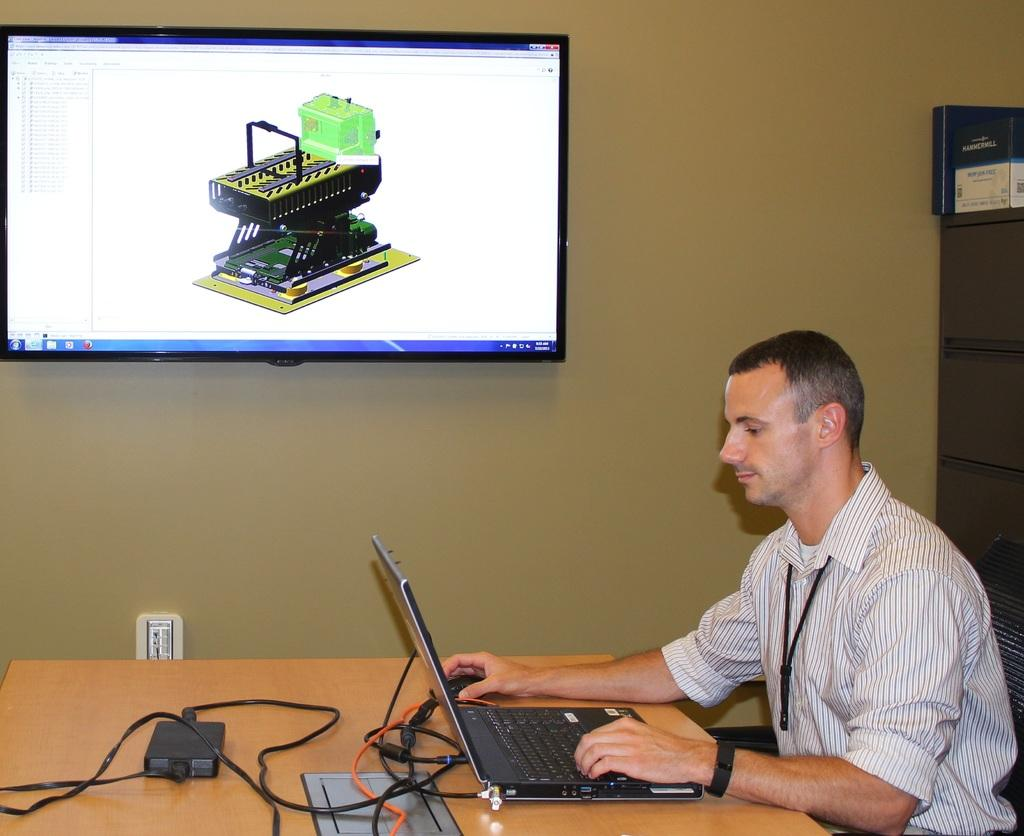What is the main object in the middle of the image? There is a TV in the middle of the image. How is the TV positioned in the image? The TV is mounted on the wall. What is the man on the right side of the image doing? The man is working on a laptop. What is the man wearing on his upper body? The man is wearing a shirt. What accessory is the man wearing on his wrist? The man is wearing a watch. What type of dirt can be seen on the TV screen in the image? There is no dirt visible on the TV screen in the image. What is the man using to stir his coffee in the image? There is no coffee or spoon present in the image. 